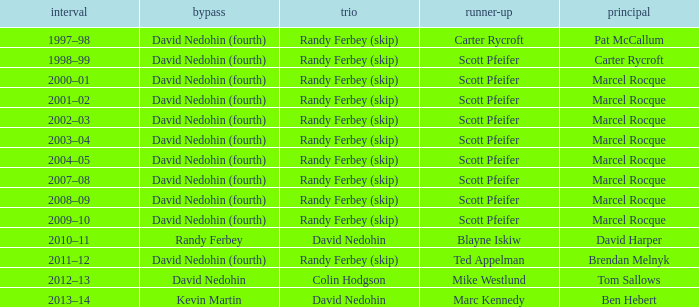Which Second has a Lead of ben hebert? Marc Kennedy. Can you parse all the data within this table? {'header': ['interval', 'bypass', 'trio', 'runner-up', 'principal'], 'rows': [['1997–98', 'David Nedohin (fourth)', 'Randy Ferbey (skip)', 'Carter Rycroft', 'Pat McCallum'], ['1998–99', 'David Nedohin (fourth)', 'Randy Ferbey (skip)', 'Scott Pfeifer', 'Carter Rycroft'], ['2000–01', 'David Nedohin (fourth)', 'Randy Ferbey (skip)', 'Scott Pfeifer', 'Marcel Rocque'], ['2001–02', 'David Nedohin (fourth)', 'Randy Ferbey (skip)', 'Scott Pfeifer', 'Marcel Rocque'], ['2002–03', 'David Nedohin (fourth)', 'Randy Ferbey (skip)', 'Scott Pfeifer', 'Marcel Rocque'], ['2003–04', 'David Nedohin (fourth)', 'Randy Ferbey (skip)', 'Scott Pfeifer', 'Marcel Rocque'], ['2004–05', 'David Nedohin (fourth)', 'Randy Ferbey (skip)', 'Scott Pfeifer', 'Marcel Rocque'], ['2007–08', 'David Nedohin (fourth)', 'Randy Ferbey (skip)', 'Scott Pfeifer', 'Marcel Rocque'], ['2008–09', 'David Nedohin (fourth)', 'Randy Ferbey (skip)', 'Scott Pfeifer', 'Marcel Rocque'], ['2009–10', 'David Nedohin (fourth)', 'Randy Ferbey (skip)', 'Scott Pfeifer', 'Marcel Rocque'], ['2010–11', 'Randy Ferbey', 'David Nedohin', 'Blayne Iskiw', 'David Harper'], ['2011–12', 'David Nedohin (fourth)', 'Randy Ferbey (skip)', 'Ted Appelman', 'Brendan Melnyk'], ['2012–13', 'David Nedohin', 'Colin Hodgson', 'Mike Westlund', 'Tom Sallows'], ['2013–14', 'Kevin Martin', 'David Nedohin', 'Marc Kennedy', 'Ben Hebert']]} 